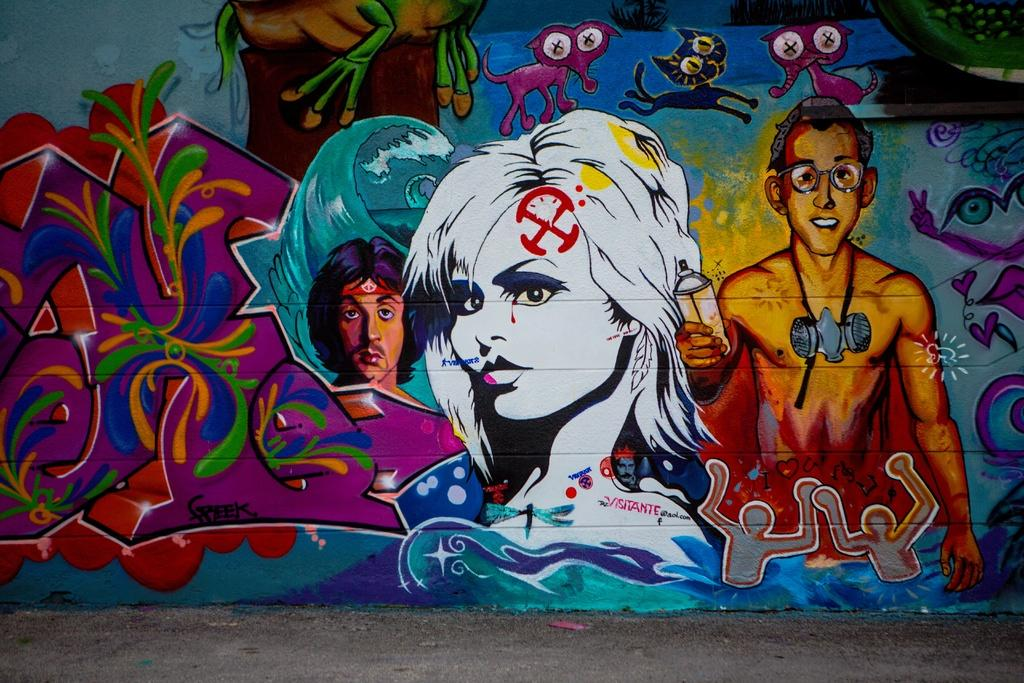What is visible at the bottom of the image? The ground is visible at the bottom of the image. What can be seen on the wall in the image? There is a painting on the wall. What subjects are depicted in the painting? The painting depicts people and animals. What type of acoustics can be heard coming from the painting in the image? There is no sound or acoustics present in the image, as it is a static painting. How many wheels are visible in the painting? There are no wheels depicted in the painting; it features people and animals. 